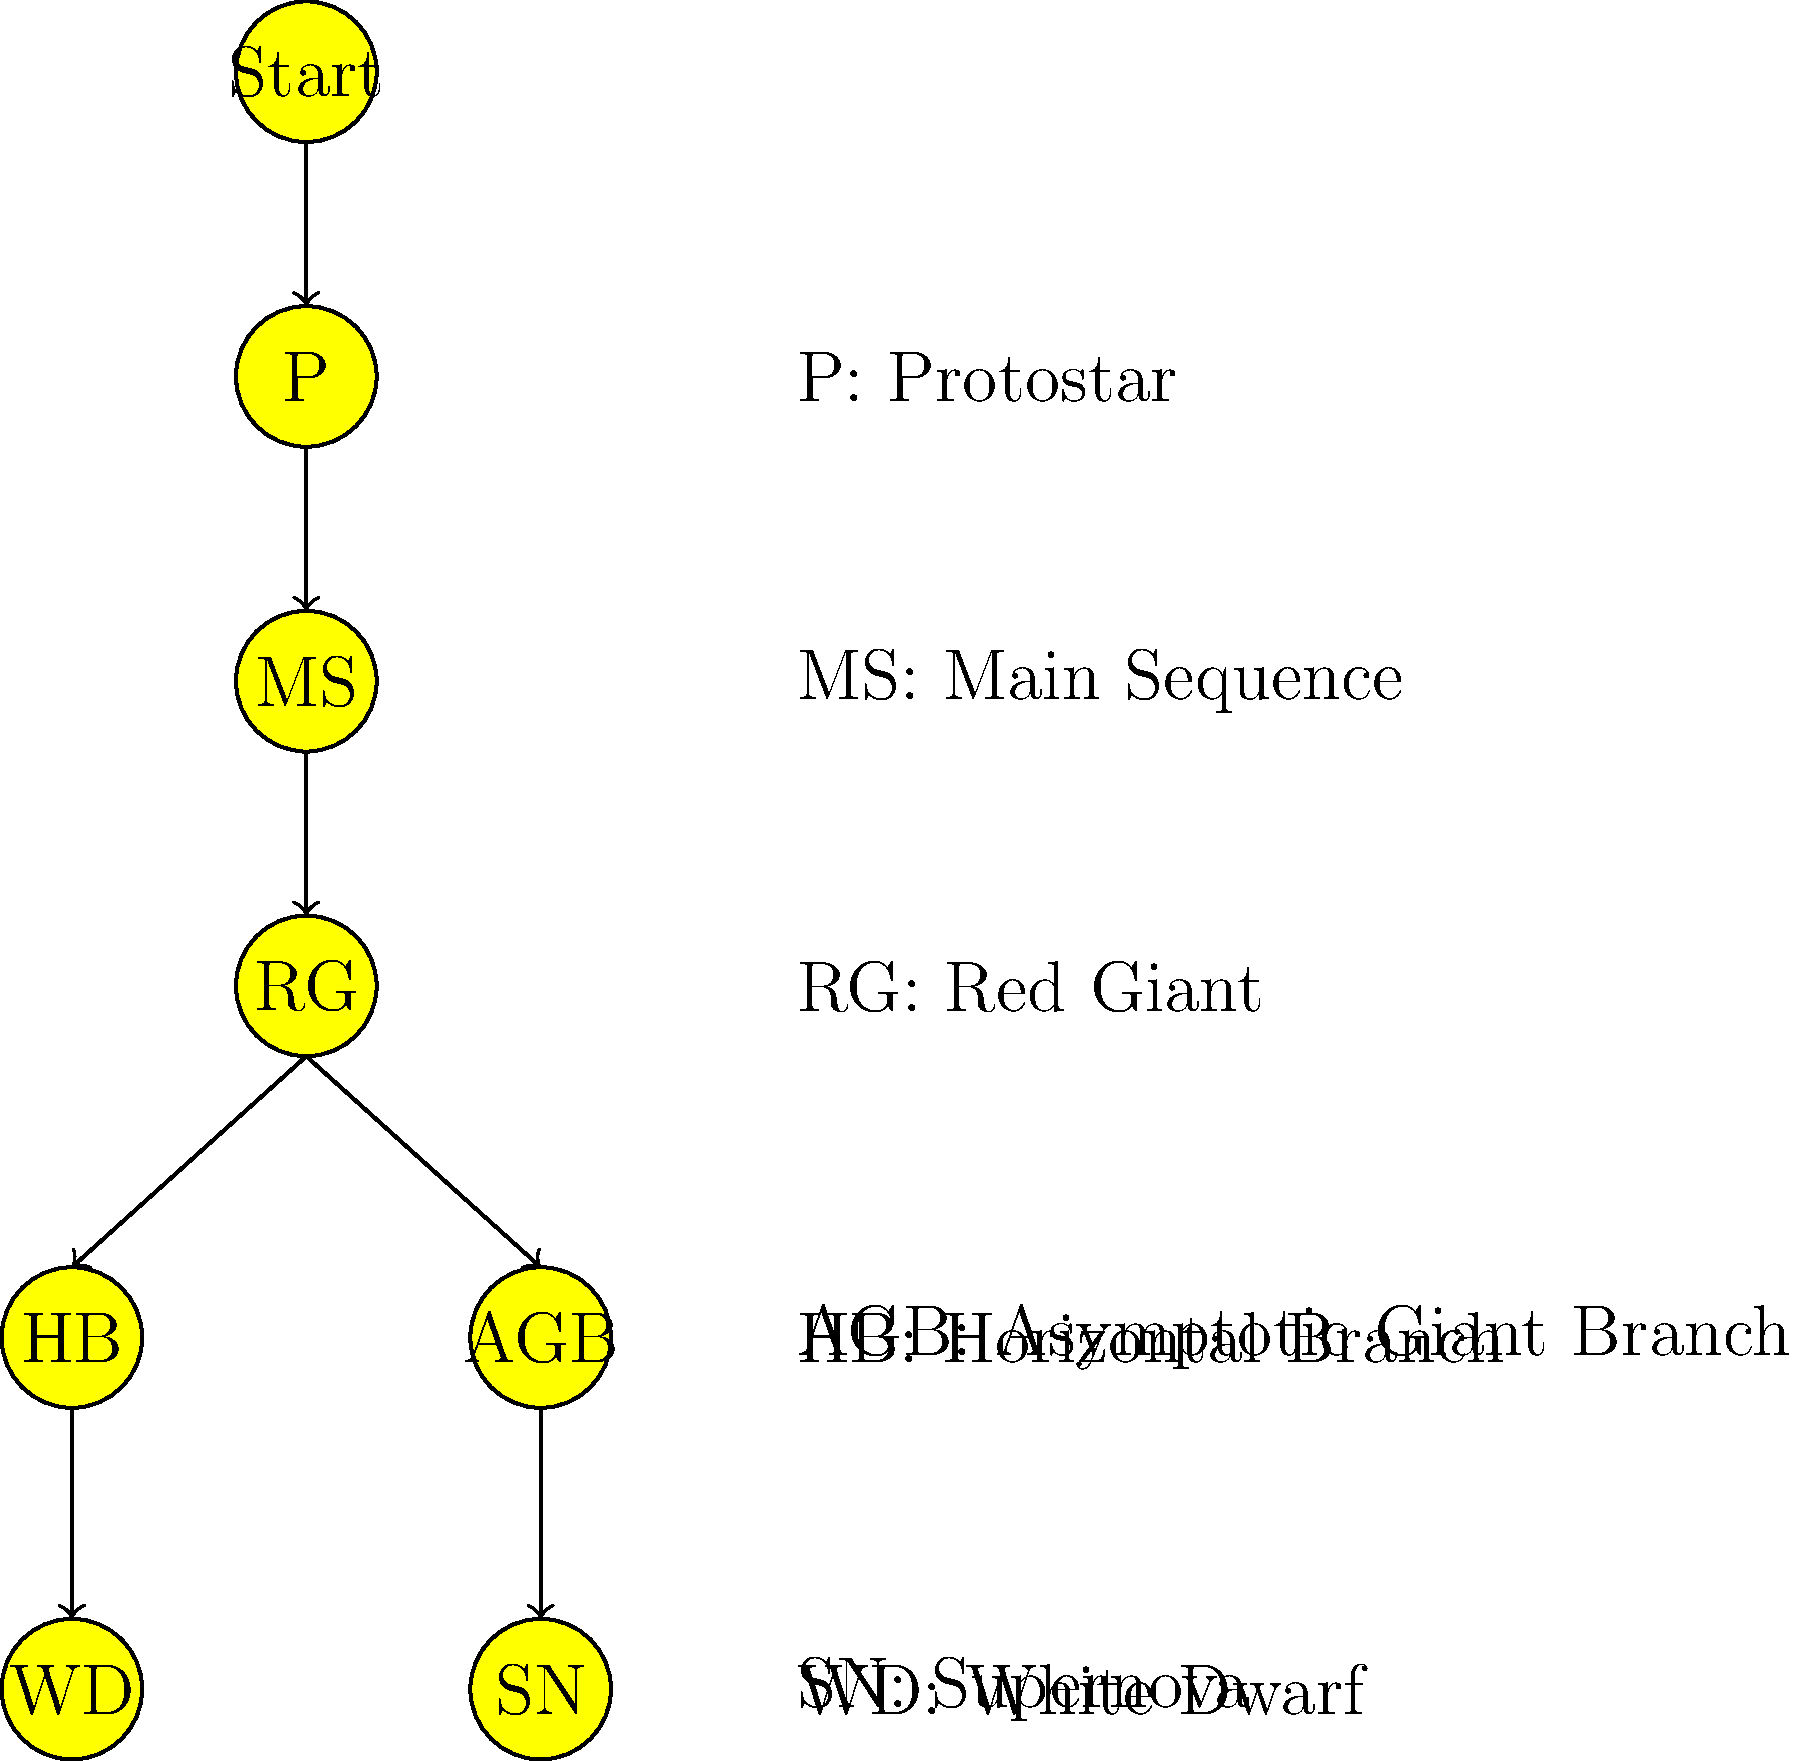In the life cycle of a star, which stage immediately precedes the formation of a white dwarf for a low to medium-mass star? To answer this question, let's follow the life cycle of a low to medium-mass star step-by-step:

1. The star begins as a protostar (P), collapsing under gravity.
2. It then enters the main sequence (MS) stage, where it spends most of its life fusing hydrogen into helium in its core.
3. After depleting its core hydrogen, the star expands and becomes a red giant (RG).
4. For low to medium-mass stars, the red giant phase is followed by the horizontal branch (HB) stage, where helium fusion occurs in the core.
5. After the horizontal branch, the star enters the asymptotic giant branch (AGB) phase, characterized by alternating hydrogen and helium shell burning.
6. Finally, the star sheds its outer layers, exposing its hot core, which cools and becomes a white dwarf (WD).

Therefore, the stage immediately preceding the formation of a white dwarf for a low to medium-mass star is the asymptotic giant branch (AGB) phase.
Answer: Asymptotic Giant Branch (AGB) 